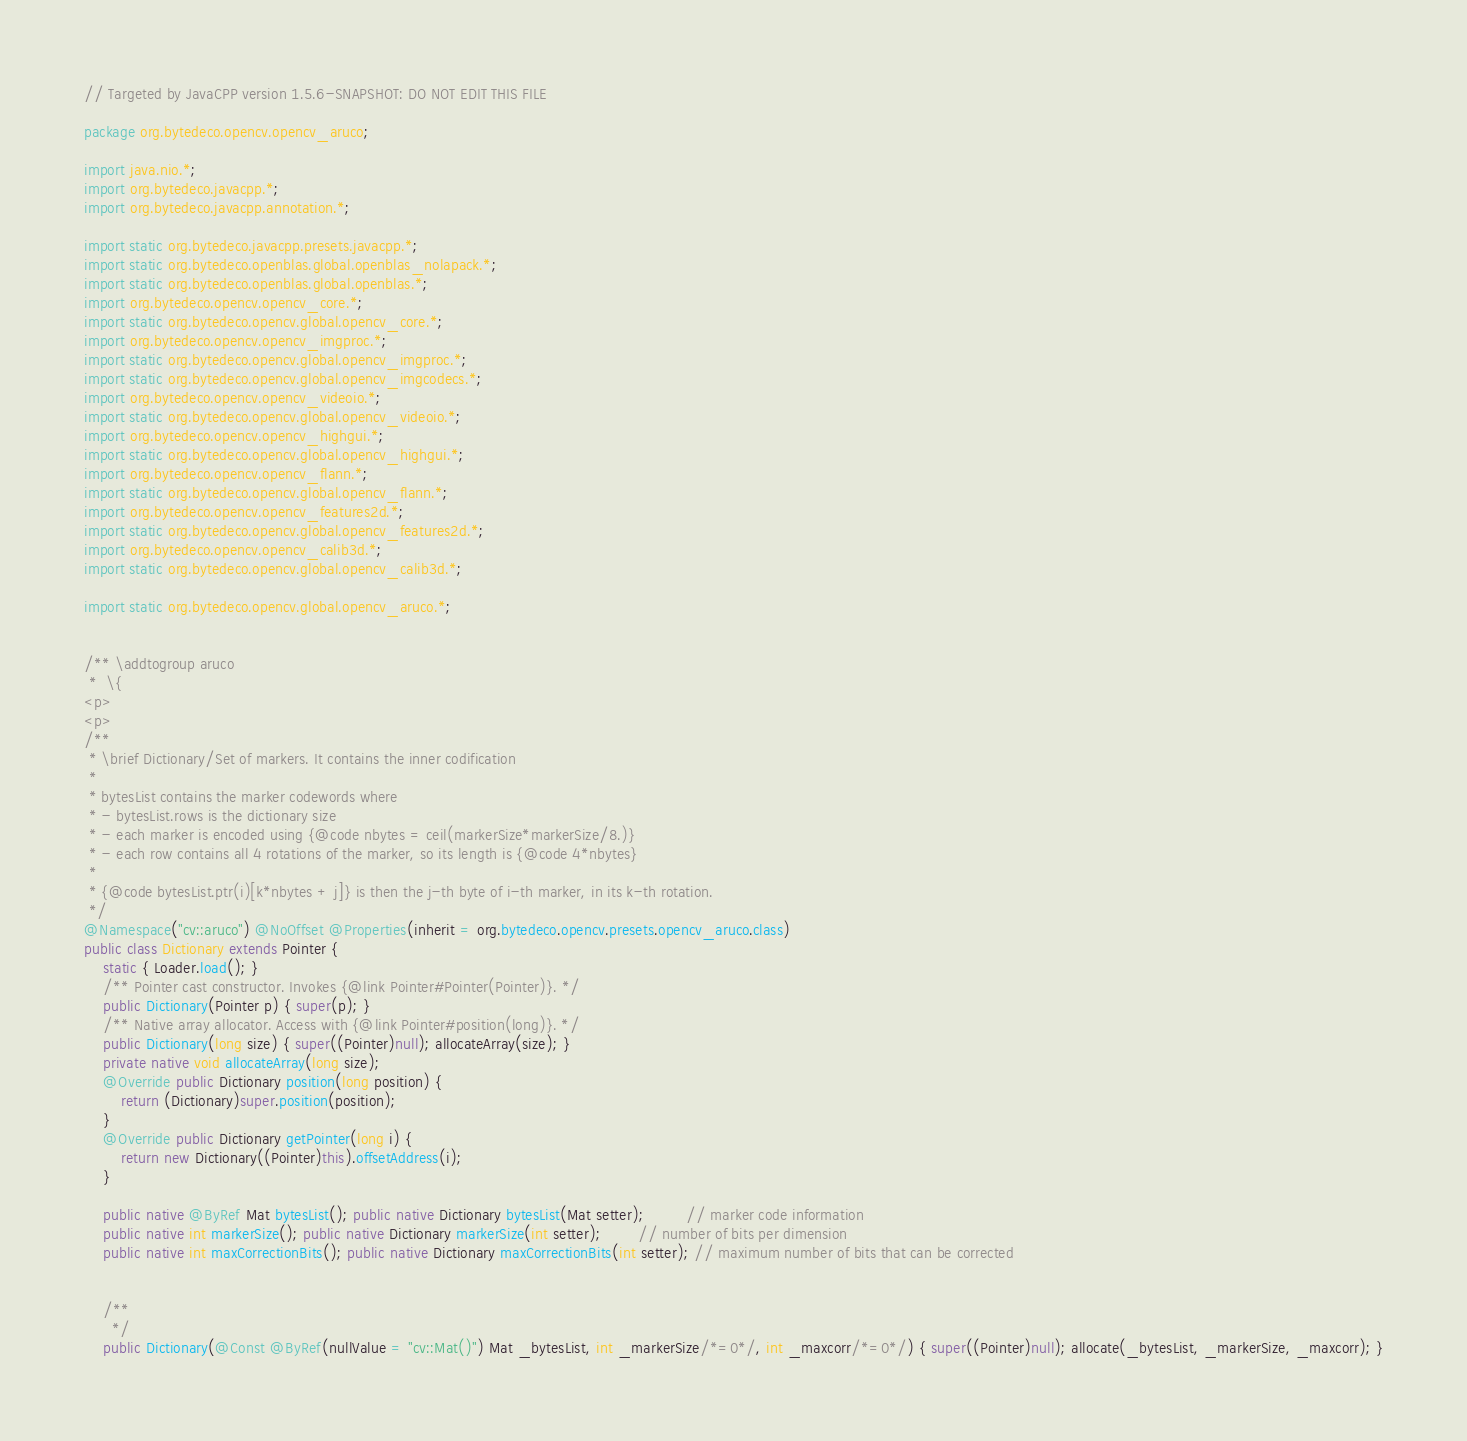<code> <loc_0><loc_0><loc_500><loc_500><_Java_>// Targeted by JavaCPP version 1.5.6-SNAPSHOT: DO NOT EDIT THIS FILE

package org.bytedeco.opencv.opencv_aruco;

import java.nio.*;
import org.bytedeco.javacpp.*;
import org.bytedeco.javacpp.annotation.*;

import static org.bytedeco.javacpp.presets.javacpp.*;
import static org.bytedeco.openblas.global.openblas_nolapack.*;
import static org.bytedeco.openblas.global.openblas.*;
import org.bytedeco.opencv.opencv_core.*;
import static org.bytedeco.opencv.global.opencv_core.*;
import org.bytedeco.opencv.opencv_imgproc.*;
import static org.bytedeco.opencv.global.opencv_imgproc.*;
import static org.bytedeco.opencv.global.opencv_imgcodecs.*;
import org.bytedeco.opencv.opencv_videoio.*;
import static org.bytedeco.opencv.global.opencv_videoio.*;
import org.bytedeco.opencv.opencv_highgui.*;
import static org.bytedeco.opencv.global.opencv_highgui.*;
import org.bytedeco.opencv.opencv_flann.*;
import static org.bytedeco.opencv.global.opencv_flann.*;
import org.bytedeco.opencv.opencv_features2d.*;
import static org.bytedeco.opencv.global.opencv_features2d.*;
import org.bytedeco.opencv.opencv_calib3d.*;
import static org.bytedeco.opencv.global.opencv_calib3d.*;

import static org.bytedeco.opencv.global.opencv_aruco.*;


/** \addtogroup aruco
 *  \{
<p>
<p>
/**
 * \brief Dictionary/Set of markers. It contains the inner codification
 *
 * bytesList contains the marker codewords where
 * - bytesList.rows is the dictionary size
 * - each marker is encoded using {@code nbytes = ceil(markerSize*markerSize/8.)}
 * - each row contains all 4 rotations of the marker, so its length is {@code 4*nbytes}
 *
 * {@code bytesList.ptr(i)[k*nbytes + j]} is then the j-th byte of i-th marker, in its k-th rotation.
 */
@Namespace("cv::aruco") @NoOffset @Properties(inherit = org.bytedeco.opencv.presets.opencv_aruco.class)
public class Dictionary extends Pointer {
    static { Loader.load(); }
    /** Pointer cast constructor. Invokes {@link Pointer#Pointer(Pointer)}. */
    public Dictionary(Pointer p) { super(p); }
    /** Native array allocator. Access with {@link Pointer#position(long)}. */
    public Dictionary(long size) { super((Pointer)null); allocateArray(size); }
    private native void allocateArray(long size);
    @Override public Dictionary position(long position) {
        return (Dictionary)super.position(position);
    }
    @Override public Dictionary getPointer(long i) {
        return new Dictionary((Pointer)this).offsetAddress(i);
    }

    public native @ByRef Mat bytesList(); public native Dictionary bytesList(Mat setter);         // marker code information
    public native int markerSize(); public native Dictionary markerSize(int setter);        // number of bits per dimension
    public native int maxCorrectionBits(); public native Dictionary maxCorrectionBits(int setter); // maximum number of bits that can be corrected


    /**
      */
    public Dictionary(@Const @ByRef(nullValue = "cv::Mat()") Mat _bytesList, int _markerSize/*=0*/, int _maxcorr/*=0*/) { super((Pointer)null); allocate(_bytesList, _markerSize, _maxcorr); }</code> 